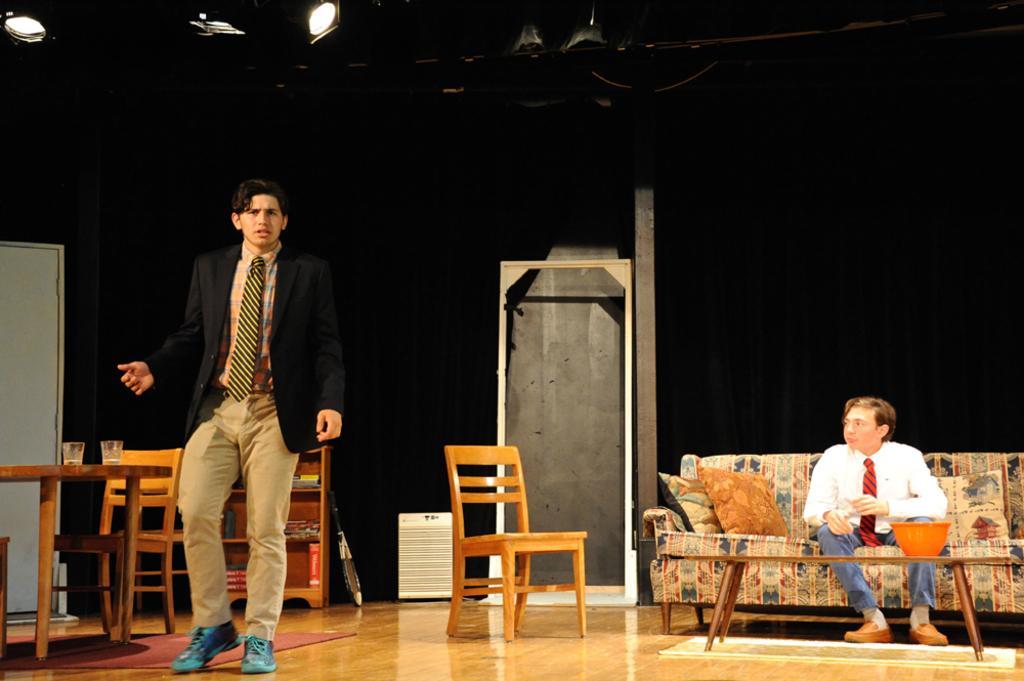How would you summarize this image in a sentence or two? This image is taken indoors. In the background there is a wall with a door. At the top of the image there are a few lights. At the bottom of the image there is a floor. On the right side of the image a man is sitting on the couch and there are a few pillows on the couch. There is a table with a few things on it. On the left side of the image there is another table with two glasses on it. There is another door and there is a cupboard with a few books. There is an empty chair and a man is standing on the floor. In the middle of the image there is an empty chair. 